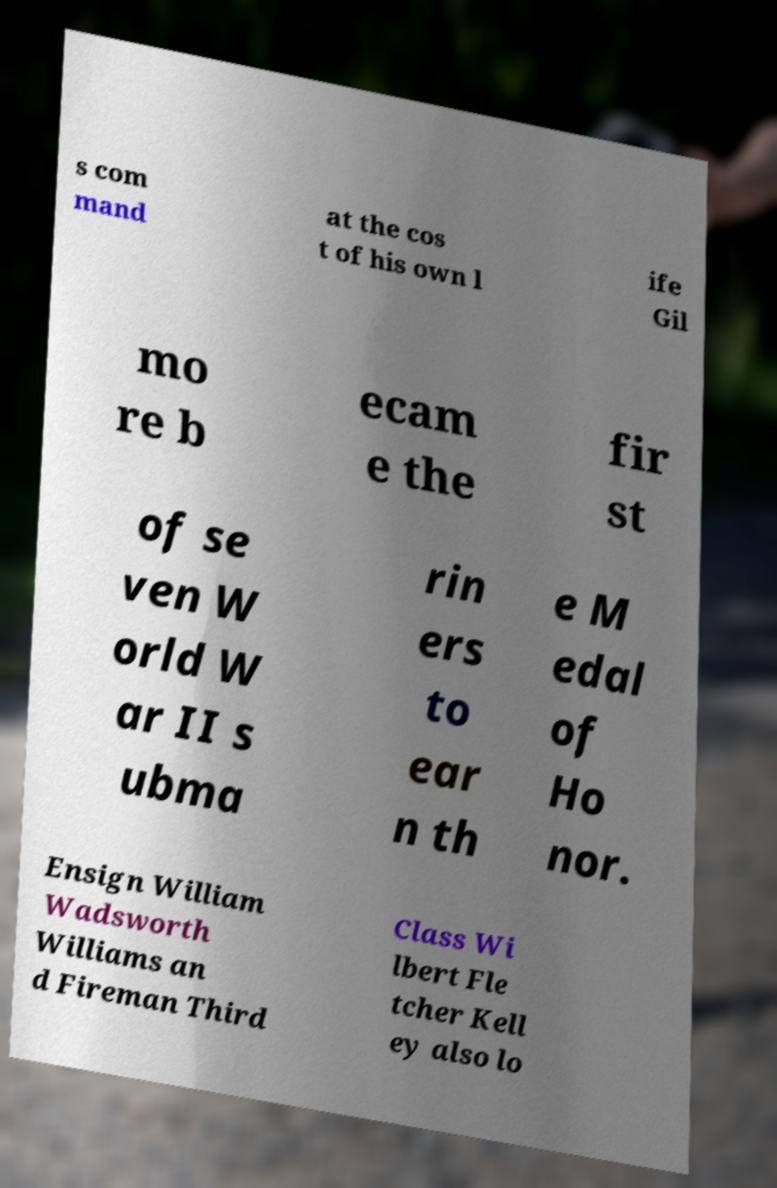Could you extract and type out the text from this image? s com mand at the cos t of his own l ife Gil mo re b ecam e the fir st of se ven W orld W ar II s ubma rin ers to ear n th e M edal of Ho nor. Ensign William Wadsworth Williams an d Fireman Third Class Wi lbert Fle tcher Kell ey also lo 